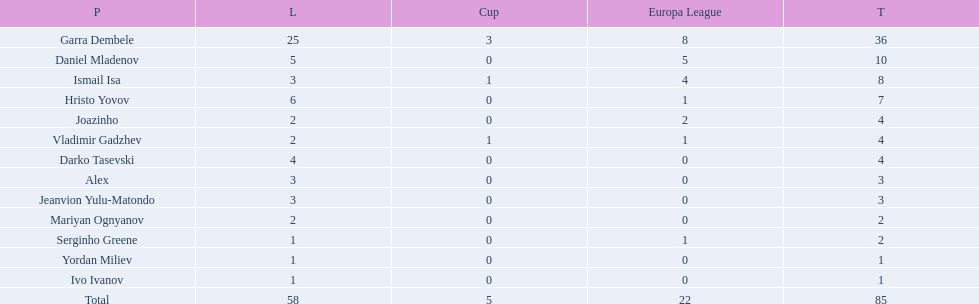Who are all of the players? Garra Dembele, Daniel Mladenov, Ismail Isa, Hristo Yovov, Joazinho, Vladimir Gadzhev, Darko Tasevski, Alex, Jeanvion Yulu-Matondo, Mariyan Ognyanov, Serginho Greene, Yordan Miliev, Ivo Ivanov. And which league is each player in? 25, 5, 3, 6, 2, 2, 4, 3, 3, 2, 1, 1, 1. Along with vladimir gadzhev and joazinho, which other player is in league 2? Mariyan Ognyanov. 